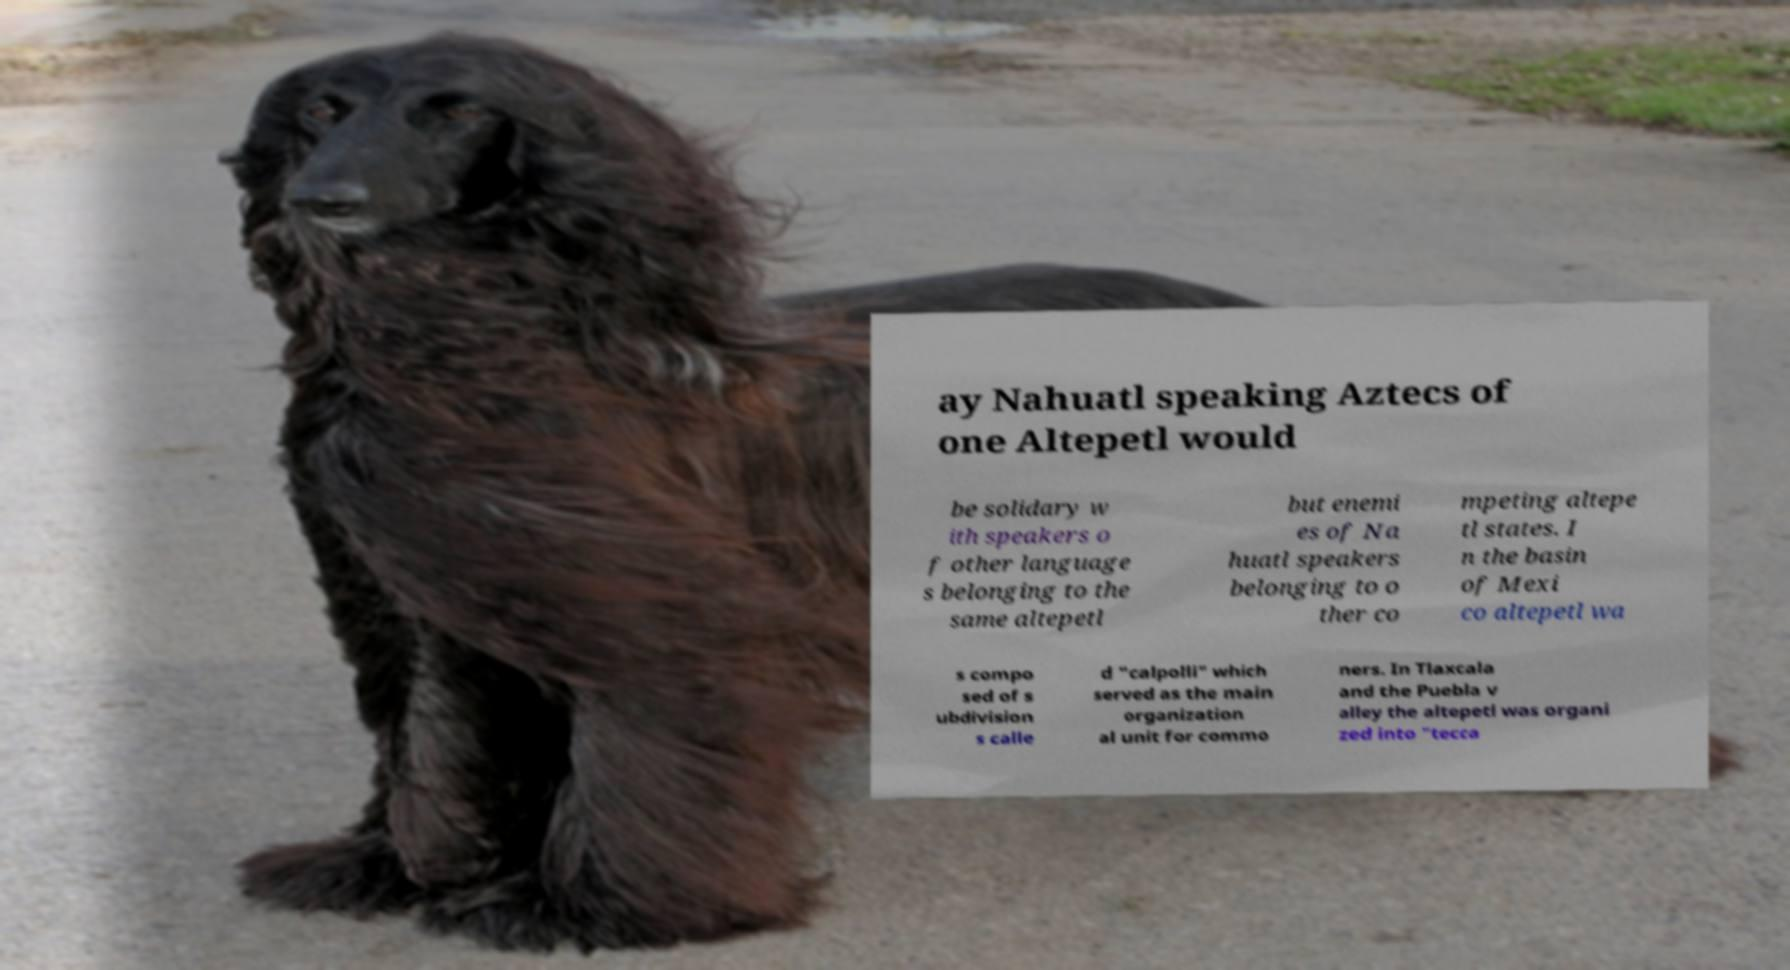Please identify and transcribe the text found in this image. ay Nahuatl speaking Aztecs of one Altepetl would be solidary w ith speakers o f other language s belonging to the same altepetl but enemi es of Na huatl speakers belonging to o ther co mpeting altepe tl states. I n the basin of Mexi co altepetl wa s compo sed of s ubdivision s calle d "calpolli" which served as the main organization al unit for commo ners. In Tlaxcala and the Puebla v alley the altepetl was organi zed into "tecca 